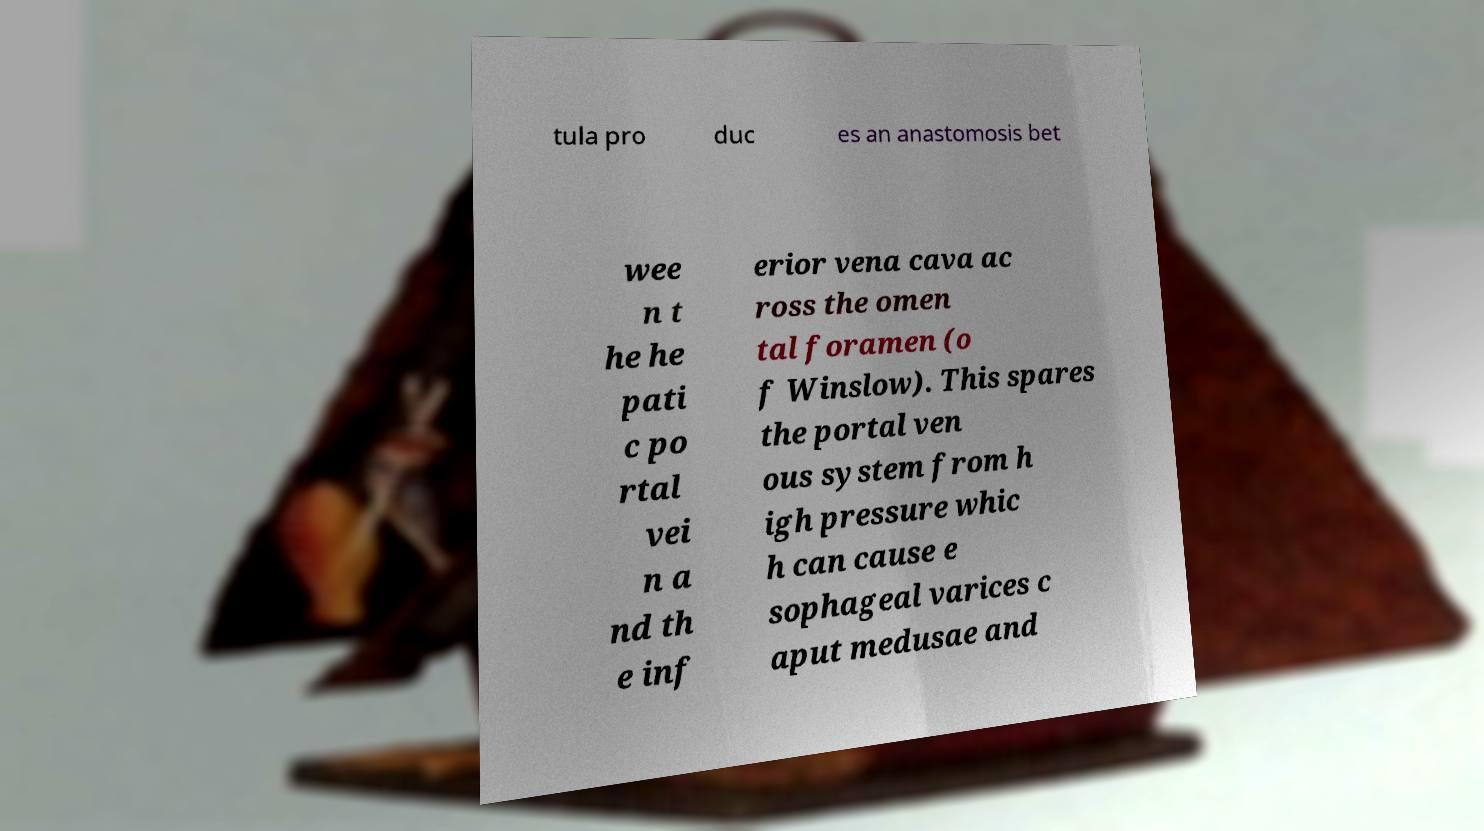For documentation purposes, I need the text within this image transcribed. Could you provide that? tula pro duc es an anastomosis bet wee n t he he pati c po rtal vei n a nd th e inf erior vena cava ac ross the omen tal foramen (o f Winslow). This spares the portal ven ous system from h igh pressure whic h can cause e sophageal varices c aput medusae and 